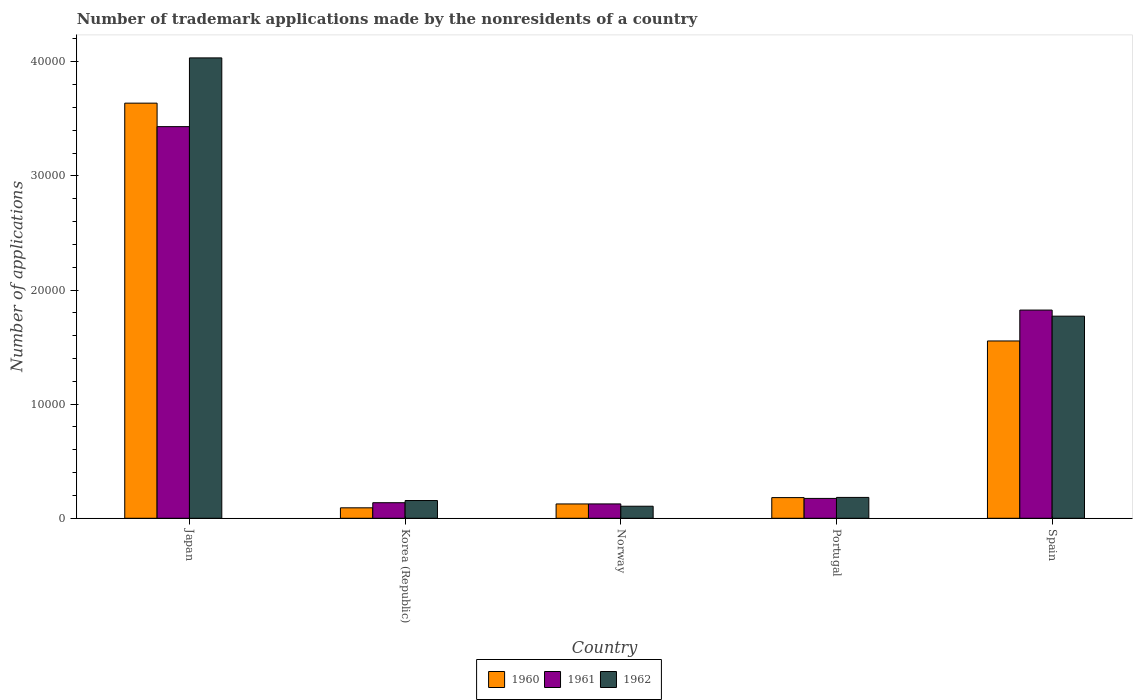How many different coloured bars are there?
Your response must be concise. 3. Are the number of bars per tick equal to the number of legend labels?
Give a very brief answer. Yes. How many bars are there on the 5th tick from the right?
Ensure brevity in your answer.  3. In how many cases, is the number of bars for a given country not equal to the number of legend labels?
Keep it short and to the point. 0. What is the number of trademark applications made by the nonresidents in 1961 in Norway?
Your answer should be very brief. 1258. Across all countries, what is the maximum number of trademark applications made by the nonresidents in 1960?
Provide a short and direct response. 3.64e+04. Across all countries, what is the minimum number of trademark applications made by the nonresidents in 1962?
Your answer should be compact. 1055. In which country was the number of trademark applications made by the nonresidents in 1961 maximum?
Your answer should be compact. Japan. In which country was the number of trademark applications made by the nonresidents in 1961 minimum?
Your response must be concise. Norway. What is the total number of trademark applications made by the nonresidents in 1961 in the graph?
Give a very brief answer. 5.69e+04. What is the difference between the number of trademark applications made by the nonresidents in 1962 in Japan and that in Spain?
Your answer should be compact. 2.26e+04. What is the difference between the number of trademark applications made by the nonresidents in 1961 in Portugal and the number of trademark applications made by the nonresidents in 1962 in Spain?
Provide a short and direct response. -1.60e+04. What is the average number of trademark applications made by the nonresidents in 1961 per country?
Your answer should be compact. 1.14e+04. What is the difference between the number of trademark applications made by the nonresidents of/in 1960 and number of trademark applications made by the nonresidents of/in 1962 in Korea (Republic)?
Make the answer very short. -638. What is the ratio of the number of trademark applications made by the nonresidents in 1961 in Japan to that in Spain?
Offer a very short reply. 1.88. Is the number of trademark applications made by the nonresidents in 1961 in Norway less than that in Spain?
Offer a terse response. Yes. Is the difference between the number of trademark applications made by the nonresidents in 1960 in Korea (Republic) and Portugal greater than the difference between the number of trademark applications made by the nonresidents in 1962 in Korea (Republic) and Portugal?
Make the answer very short. No. What is the difference between the highest and the second highest number of trademark applications made by the nonresidents in 1960?
Offer a very short reply. -3.46e+04. What is the difference between the highest and the lowest number of trademark applications made by the nonresidents in 1962?
Offer a very short reply. 3.93e+04. In how many countries, is the number of trademark applications made by the nonresidents in 1961 greater than the average number of trademark applications made by the nonresidents in 1961 taken over all countries?
Your response must be concise. 2. Is it the case that in every country, the sum of the number of trademark applications made by the nonresidents in 1960 and number of trademark applications made by the nonresidents in 1962 is greater than the number of trademark applications made by the nonresidents in 1961?
Your answer should be compact. Yes. How many bars are there?
Keep it short and to the point. 15. Are all the bars in the graph horizontal?
Your answer should be compact. No. How many countries are there in the graph?
Make the answer very short. 5. Are the values on the major ticks of Y-axis written in scientific E-notation?
Your answer should be compact. No. Where does the legend appear in the graph?
Offer a terse response. Bottom center. How many legend labels are there?
Keep it short and to the point. 3. How are the legend labels stacked?
Your answer should be very brief. Horizontal. What is the title of the graph?
Offer a terse response. Number of trademark applications made by the nonresidents of a country. Does "1984" appear as one of the legend labels in the graph?
Make the answer very short. No. What is the label or title of the Y-axis?
Make the answer very short. Number of applications. What is the Number of applications in 1960 in Japan?
Keep it short and to the point. 3.64e+04. What is the Number of applications in 1961 in Japan?
Your answer should be compact. 3.43e+04. What is the Number of applications of 1962 in Japan?
Offer a terse response. 4.03e+04. What is the Number of applications of 1960 in Korea (Republic)?
Your answer should be compact. 916. What is the Number of applications of 1961 in Korea (Republic)?
Your answer should be very brief. 1363. What is the Number of applications in 1962 in Korea (Republic)?
Keep it short and to the point. 1554. What is the Number of applications of 1960 in Norway?
Your answer should be very brief. 1255. What is the Number of applications of 1961 in Norway?
Make the answer very short. 1258. What is the Number of applications in 1962 in Norway?
Keep it short and to the point. 1055. What is the Number of applications in 1960 in Portugal?
Offer a very short reply. 1811. What is the Number of applications of 1961 in Portugal?
Your answer should be very brief. 1740. What is the Number of applications of 1962 in Portugal?
Your answer should be compact. 1828. What is the Number of applications in 1960 in Spain?
Your answer should be very brief. 1.55e+04. What is the Number of applications in 1961 in Spain?
Your answer should be compact. 1.82e+04. What is the Number of applications of 1962 in Spain?
Provide a succinct answer. 1.77e+04. Across all countries, what is the maximum Number of applications of 1960?
Provide a succinct answer. 3.64e+04. Across all countries, what is the maximum Number of applications of 1961?
Your answer should be very brief. 3.43e+04. Across all countries, what is the maximum Number of applications of 1962?
Give a very brief answer. 4.03e+04. Across all countries, what is the minimum Number of applications of 1960?
Provide a succinct answer. 916. Across all countries, what is the minimum Number of applications of 1961?
Keep it short and to the point. 1258. Across all countries, what is the minimum Number of applications of 1962?
Offer a very short reply. 1055. What is the total Number of applications of 1960 in the graph?
Provide a short and direct response. 5.59e+04. What is the total Number of applications in 1961 in the graph?
Make the answer very short. 5.69e+04. What is the total Number of applications in 1962 in the graph?
Keep it short and to the point. 6.25e+04. What is the difference between the Number of applications of 1960 in Japan and that in Korea (Republic)?
Offer a terse response. 3.55e+04. What is the difference between the Number of applications of 1961 in Japan and that in Korea (Republic)?
Offer a terse response. 3.30e+04. What is the difference between the Number of applications in 1962 in Japan and that in Korea (Republic)?
Offer a terse response. 3.88e+04. What is the difference between the Number of applications in 1960 in Japan and that in Norway?
Give a very brief answer. 3.51e+04. What is the difference between the Number of applications in 1961 in Japan and that in Norway?
Provide a short and direct response. 3.31e+04. What is the difference between the Number of applications in 1962 in Japan and that in Norway?
Your answer should be compact. 3.93e+04. What is the difference between the Number of applications of 1960 in Japan and that in Portugal?
Make the answer very short. 3.46e+04. What is the difference between the Number of applications in 1961 in Japan and that in Portugal?
Keep it short and to the point. 3.26e+04. What is the difference between the Number of applications of 1962 in Japan and that in Portugal?
Offer a terse response. 3.85e+04. What is the difference between the Number of applications in 1960 in Japan and that in Spain?
Your response must be concise. 2.08e+04. What is the difference between the Number of applications in 1961 in Japan and that in Spain?
Your response must be concise. 1.61e+04. What is the difference between the Number of applications of 1962 in Japan and that in Spain?
Your answer should be very brief. 2.26e+04. What is the difference between the Number of applications of 1960 in Korea (Republic) and that in Norway?
Offer a terse response. -339. What is the difference between the Number of applications of 1961 in Korea (Republic) and that in Norway?
Offer a terse response. 105. What is the difference between the Number of applications in 1962 in Korea (Republic) and that in Norway?
Your answer should be compact. 499. What is the difference between the Number of applications of 1960 in Korea (Republic) and that in Portugal?
Make the answer very short. -895. What is the difference between the Number of applications of 1961 in Korea (Republic) and that in Portugal?
Make the answer very short. -377. What is the difference between the Number of applications of 1962 in Korea (Republic) and that in Portugal?
Offer a very short reply. -274. What is the difference between the Number of applications in 1960 in Korea (Republic) and that in Spain?
Your answer should be very brief. -1.46e+04. What is the difference between the Number of applications in 1961 in Korea (Republic) and that in Spain?
Provide a short and direct response. -1.69e+04. What is the difference between the Number of applications in 1962 in Korea (Republic) and that in Spain?
Make the answer very short. -1.62e+04. What is the difference between the Number of applications of 1960 in Norway and that in Portugal?
Keep it short and to the point. -556. What is the difference between the Number of applications of 1961 in Norway and that in Portugal?
Your answer should be compact. -482. What is the difference between the Number of applications of 1962 in Norway and that in Portugal?
Your response must be concise. -773. What is the difference between the Number of applications of 1960 in Norway and that in Spain?
Your answer should be compact. -1.43e+04. What is the difference between the Number of applications in 1961 in Norway and that in Spain?
Provide a succinct answer. -1.70e+04. What is the difference between the Number of applications of 1962 in Norway and that in Spain?
Give a very brief answer. -1.67e+04. What is the difference between the Number of applications of 1960 in Portugal and that in Spain?
Offer a very short reply. -1.37e+04. What is the difference between the Number of applications of 1961 in Portugal and that in Spain?
Ensure brevity in your answer.  -1.65e+04. What is the difference between the Number of applications of 1962 in Portugal and that in Spain?
Keep it short and to the point. -1.59e+04. What is the difference between the Number of applications of 1960 in Japan and the Number of applications of 1961 in Korea (Republic)?
Your answer should be compact. 3.50e+04. What is the difference between the Number of applications in 1960 in Japan and the Number of applications in 1962 in Korea (Republic)?
Offer a terse response. 3.48e+04. What is the difference between the Number of applications in 1961 in Japan and the Number of applications in 1962 in Korea (Republic)?
Ensure brevity in your answer.  3.28e+04. What is the difference between the Number of applications in 1960 in Japan and the Number of applications in 1961 in Norway?
Provide a succinct answer. 3.51e+04. What is the difference between the Number of applications in 1960 in Japan and the Number of applications in 1962 in Norway?
Offer a very short reply. 3.53e+04. What is the difference between the Number of applications of 1961 in Japan and the Number of applications of 1962 in Norway?
Your response must be concise. 3.33e+04. What is the difference between the Number of applications of 1960 in Japan and the Number of applications of 1961 in Portugal?
Your answer should be very brief. 3.46e+04. What is the difference between the Number of applications of 1960 in Japan and the Number of applications of 1962 in Portugal?
Offer a terse response. 3.45e+04. What is the difference between the Number of applications in 1961 in Japan and the Number of applications in 1962 in Portugal?
Offer a terse response. 3.25e+04. What is the difference between the Number of applications of 1960 in Japan and the Number of applications of 1961 in Spain?
Your answer should be compact. 1.81e+04. What is the difference between the Number of applications of 1960 in Japan and the Number of applications of 1962 in Spain?
Ensure brevity in your answer.  1.87e+04. What is the difference between the Number of applications of 1961 in Japan and the Number of applications of 1962 in Spain?
Make the answer very short. 1.66e+04. What is the difference between the Number of applications in 1960 in Korea (Republic) and the Number of applications in 1961 in Norway?
Keep it short and to the point. -342. What is the difference between the Number of applications of 1960 in Korea (Republic) and the Number of applications of 1962 in Norway?
Provide a short and direct response. -139. What is the difference between the Number of applications in 1961 in Korea (Republic) and the Number of applications in 1962 in Norway?
Provide a succinct answer. 308. What is the difference between the Number of applications of 1960 in Korea (Republic) and the Number of applications of 1961 in Portugal?
Offer a terse response. -824. What is the difference between the Number of applications in 1960 in Korea (Republic) and the Number of applications in 1962 in Portugal?
Your response must be concise. -912. What is the difference between the Number of applications in 1961 in Korea (Republic) and the Number of applications in 1962 in Portugal?
Give a very brief answer. -465. What is the difference between the Number of applications of 1960 in Korea (Republic) and the Number of applications of 1961 in Spain?
Your answer should be compact. -1.73e+04. What is the difference between the Number of applications of 1960 in Korea (Republic) and the Number of applications of 1962 in Spain?
Provide a short and direct response. -1.68e+04. What is the difference between the Number of applications in 1961 in Korea (Republic) and the Number of applications in 1962 in Spain?
Provide a succinct answer. -1.63e+04. What is the difference between the Number of applications in 1960 in Norway and the Number of applications in 1961 in Portugal?
Your response must be concise. -485. What is the difference between the Number of applications in 1960 in Norway and the Number of applications in 1962 in Portugal?
Your response must be concise. -573. What is the difference between the Number of applications of 1961 in Norway and the Number of applications of 1962 in Portugal?
Your answer should be compact. -570. What is the difference between the Number of applications of 1960 in Norway and the Number of applications of 1961 in Spain?
Give a very brief answer. -1.70e+04. What is the difference between the Number of applications in 1960 in Norway and the Number of applications in 1962 in Spain?
Offer a terse response. -1.65e+04. What is the difference between the Number of applications of 1961 in Norway and the Number of applications of 1962 in Spain?
Provide a short and direct response. -1.65e+04. What is the difference between the Number of applications of 1960 in Portugal and the Number of applications of 1961 in Spain?
Make the answer very short. -1.64e+04. What is the difference between the Number of applications of 1960 in Portugal and the Number of applications of 1962 in Spain?
Your response must be concise. -1.59e+04. What is the difference between the Number of applications of 1961 in Portugal and the Number of applications of 1962 in Spain?
Your response must be concise. -1.60e+04. What is the average Number of applications in 1960 per country?
Your answer should be very brief. 1.12e+04. What is the average Number of applications of 1961 per country?
Provide a succinct answer. 1.14e+04. What is the average Number of applications of 1962 per country?
Give a very brief answer. 1.25e+04. What is the difference between the Number of applications in 1960 and Number of applications in 1961 in Japan?
Provide a succinct answer. 2057. What is the difference between the Number of applications in 1960 and Number of applications in 1962 in Japan?
Make the answer very short. -3966. What is the difference between the Number of applications in 1961 and Number of applications in 1962 in Japan?
Your response must be concise. -6023. What is the difference between the Number of applications of 1960 and Number of applications of 1961 in Korea (Republic)?
Offer a terse response. -447. What is the difference between the Number of applications in 1960 and Number of applications in 1962 in Korea (Republic)?
Keep it short and to the point. -638. What is the difference between the Number of applications of 1961 and Number of applications of 1962 in Korea (Republic)?
Your answer should be compact. -191. What is the difference between the Number of applications of 1960 and Number of applications of 1962 in Norway?
Offer a very short reply. 200. What is the difference between the Number of applications of 1961 and Number of applications of 1962 in Norway?
Offer a very short reply. 203. What is the difference between the Number of applications in 1961 and Number of applications in 1962 in Portugal?
Provide a succinct answer. -88. What is the difference between the Number of applications of 1960 and Number of applications of 1961 in Spain?
Make the answer very short. -2707. What is the difference between the Number of applications of 1960 and Number of applications of 1962 in Spain?
Your answer should be compact. -2173. What is the difference between the Number of applications of 1961 and Number of applications of 1962 in Spain?
Ensure brevity in your answer.  534. What is the ratio of the Number of applications in 1960 in Japan to that in Korea (Republic)?
Ensure brevity in your answer.  39.71. What is the ratio of the Number of applications in 1961 in Japan to that in Korea (Republic)?
Ensure brevity in your answer.  25.18. What is the ratio of the Number of applications of 1962 in Japan to that in Korea (Republic)?
Ensure brevity in your answer.  25.96. What is the ratio of the Number of applications in 1960 in Japan to that in Norway?
Your response must be concise. 28.99. What is the ratio of the Number of applications of 1961 in Japan to that in Norway?
Your answer should be very brief. 27.28. What is the ratio of the Number of applications in 1962 in Japan to that in Norway?
Offer a terse response. 38.24. What is the ratio of the Number of applications of 1960 in Japan to that in Portugal?
Ensure brevity in your answer.  20.09. What is the ratio of the Number of applications in 1961 in Japan to that in Portugal?
Make the answer very short. 19.72. What is the ratio of the Number of applications of 1962 in Japan to that in Portugal?
Keep it short and to the point. 22.07. What is the ratio of the Number of applications in 1960 in Japan to that in Spain?
Your response must be concise. 2.34. What is the ratio of the Number of applications of 1961 in Japan to that in Spain?
Provide a short and direct response. 1.88. What is the ratio of the Number of applications of 1962 in Japan to that in Spain?
Provide a short and direct response. 2.28. What is the ratio of the Number of applications in 1960 in Korea (Republic) to that in Norway?
Your response must be concise. 0.73. What is the ratio of the Number of applications of 1961 in Korea (Republic) to that in Norway?
Give a very brief answer. 1.08. What is the ratio of the Number of applications of 1962 in Korea (Republic) to that in Norway?
Keep it short and to the point. 1.47. What is the ratio of the Number of applications of 1960 in Korea (Republic) to that in Portugal?
Keep it short and to the point. 0.51. What is the ratio of the Number of applications in 1961 in Korea (Republic) to that in Portugal?
Make the answer very short. 0.78. What is the ratio of the Number of applications in 1962 in Korea (Republic) to that in Portugal?
Provide a succinct answer. 0.85. What is the ratio of the Number of applications of 1960 in Korea (Republic) to that in Spain?
Ensure brevity in your answer.  0.06. What is the ratio of the Number of applications in 1961 in Korea (Republic) to that in Spain?
Your answer should be compact. 0.07. What is the ratio of the Number of applications of 1962 in Korea (Republic) to that in Spain?
Offer a very short reply. 0.09. What is the ratio of the Number of applications of 1960 in Norway to that in Portugal?
Your response must be concise. 0.69. What is the ratio of the Number of applications of 1961 in Norway to that in Portugal?
Your answer should be very brief. 0.72. What is the ratio of the Number of applications of 1962 in Norway to that in Portugal?
Offer a terse response. 0.58. What is the ratio of the Number of applications of 1960 in Norway to that in Spain?
Provide a short and direct response. 0.08. What is the ratio of the Number of applications of 1961 in Norway to that in Spain?
Offer a terse response. 0.07. What is the ratio of the Number of applications in 1962 in Norway to that in Spain?
Your response must be concise. 0.06. What is the ratio of the Number of applications of 1960 in Portugal to that in Spain?
Your answer should be very brief. 0.12. What is the ratio of the Number of applications of 1961 in Portugal to that in Spain?
Provide a succinct answer. 0.1. What is the ratio of the Number of applications of 1962 in Portugal to that in Spain?
Give a very brief answer. 0.1. What is the difference between the highest and the second highest Number of applications of 1960?
Provide a succinct answer. 2.08e+04. What is the difference between the highest and the second highest Number of applications of 1961?
Offer a terse response. 1.61e+04. What is the difference between the highest and the second highest Number of applications of 1962?
Your answer should be compact. 2.26e+04. What is the difference between the highest and the lowest Number of applications of 1960?
Keep it short and to the point. 3.55e+04. What is the difference between the highest and the lowest Number of applications in 1961?
Make the answer very short. 3.31e+04. What is the difference between the highest and the lowest Number of applications in 1962?
Your answer should be very brief. 3.93e+04. 